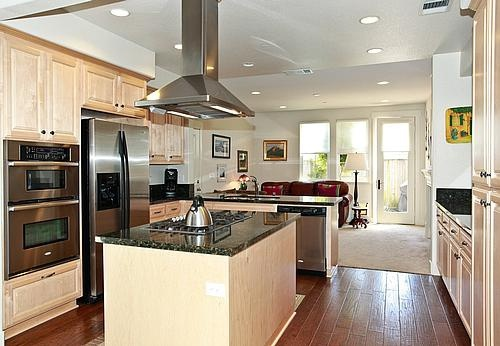Describe the objects in this image and their specific colors. I can see refrigerator in white, black, darkgray, gray, and maroon tones, oven in white, maroon, black, and darkgreen tones, oven in white, black, gray, and maroon tones, couch in white, black, maroon, gray, and darkgray tones, and sink in white, black, darkgray, and gray tones in this image. 